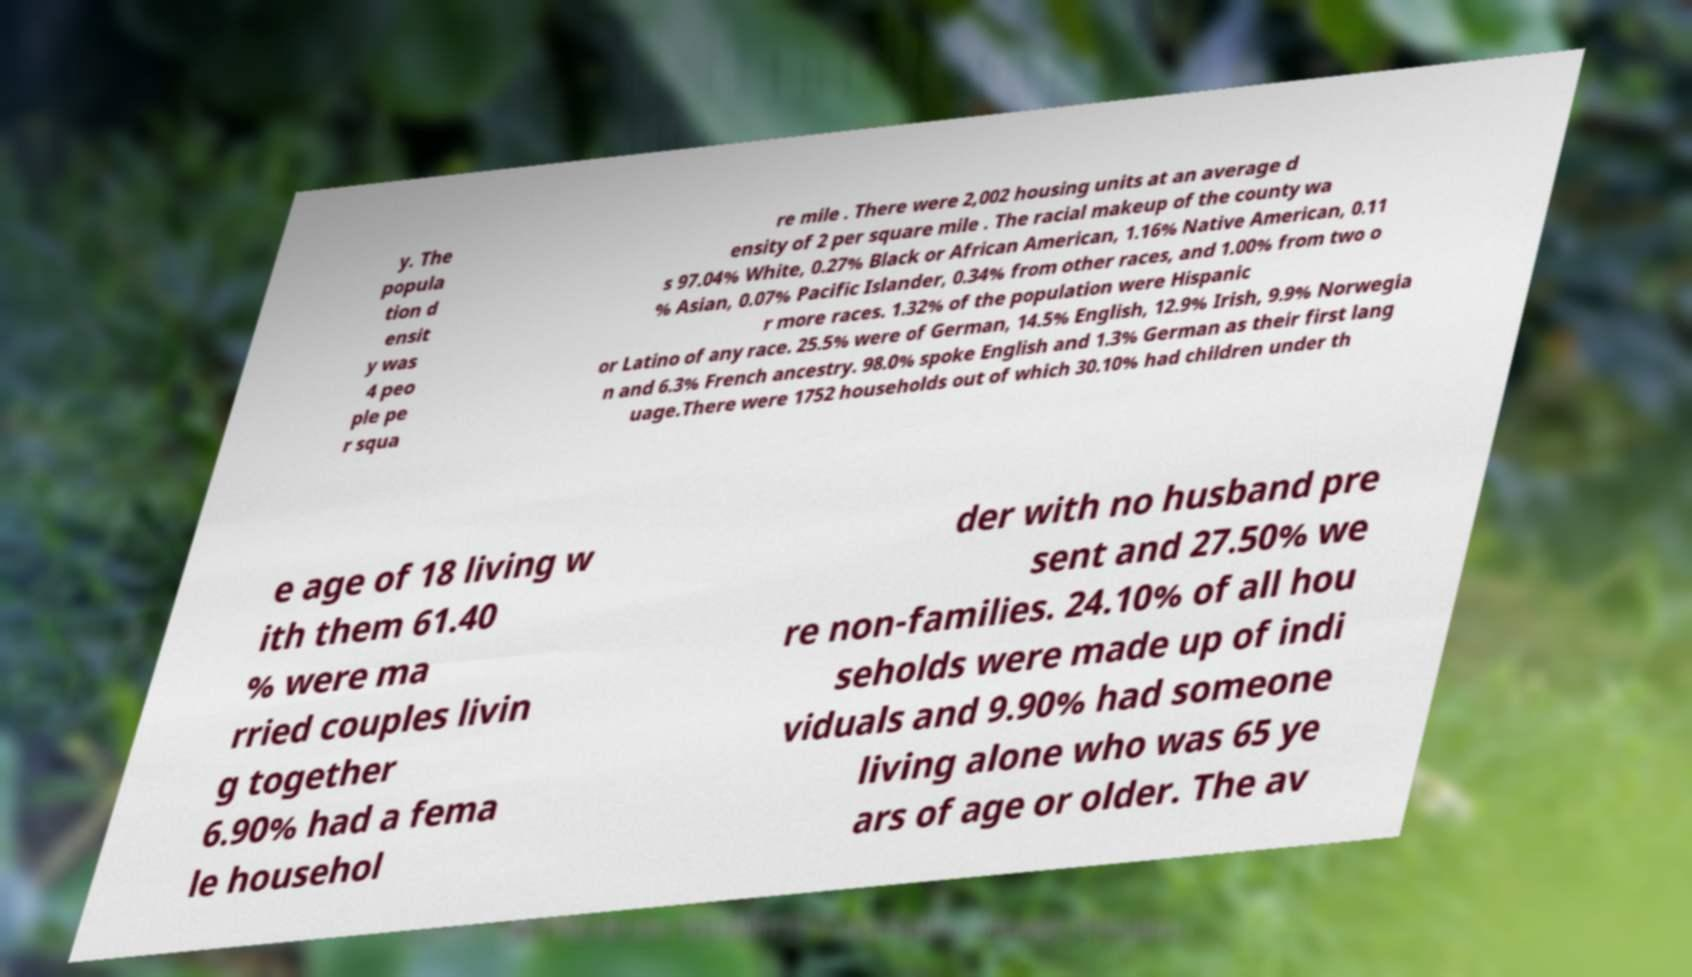I need the written content from this picture converted into text. Can you do that? y. The popula tion d ensit y was 4 peo ple pe r squa re mile . There were 2,002 housing units at an average d ensity of 2 per square mile . The racial makeup of the county wa s 97.04% White, 0.27% Black or African American, 1.16% Native American, 0.11 % Asian, 0.07% Pacific Islander, 0.34% from other races, and 1.00% from two o r more races. 1.32% of the population were Hispanic or Latino of any race. 25.5% were of German, 14.5% English, 12.9% Irish, 9.9% Norwegia n and 6.3% French ancestry. 98.0% spoke English and 1.3% German as their first lang uage.There were 1752 households out of which 30.10% had children under th e age of 18 living w ith them 61.40 % were ma rried couples livin g together 6.90% had a fema le househol der with no husband pre sent and 27.50% we re non-families. 24.10% of all hou seholds were made up of indi viduals and 9.90% had someone living alone who was 65 ye ars of age or older. The av 